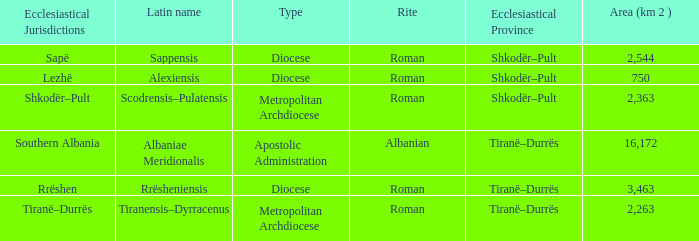What Ecclesiastical Province has a type diocese and a latin name alexiensis? Shkodër–Pult. 